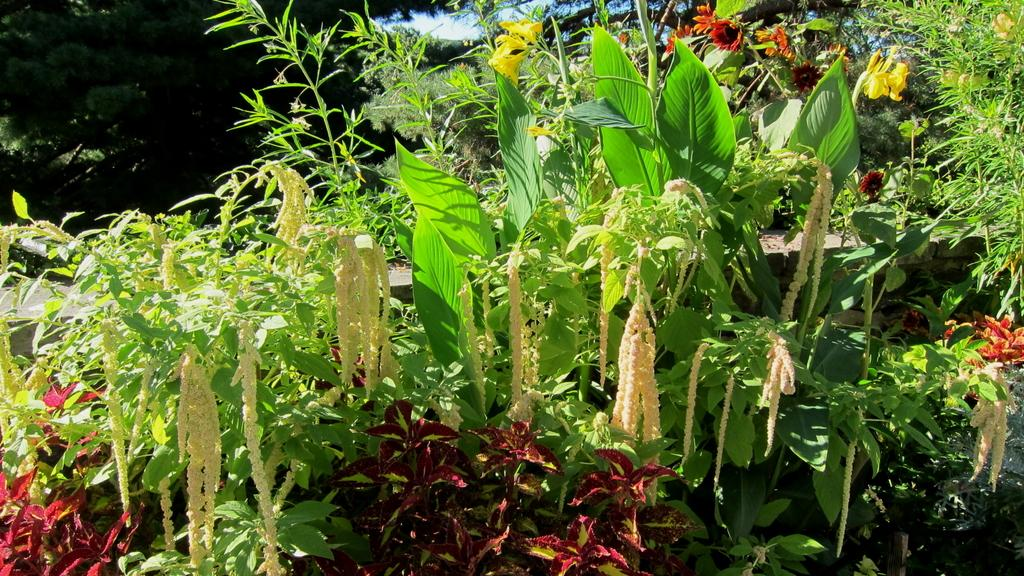What type of vegetation can be seen in the image? There are flowers, plants, and trees in the image. What can be seen in the background of the image? The sky is visible in the background of the image. What type of soda is being advertised in the image? There is no soda or advertisement present in the image; it features flowers, plants, trees, and the sky. 